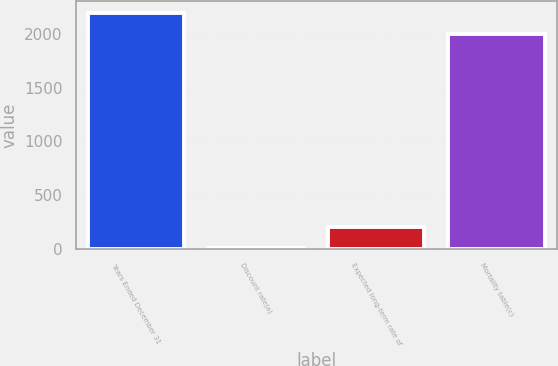Convert chart to OTSL. <chart><loc_0><loc_0><loc_500><loc_500><bar_chart><fcel>Years Ended December 31<fcel>Discount rate(a)<fcel>Expected long-term rate of<fcel>Mortality table(c)<nl><fcel>2200.16<fcel>6.4<fcel>206.56<fcel>2000<nl></chart> 